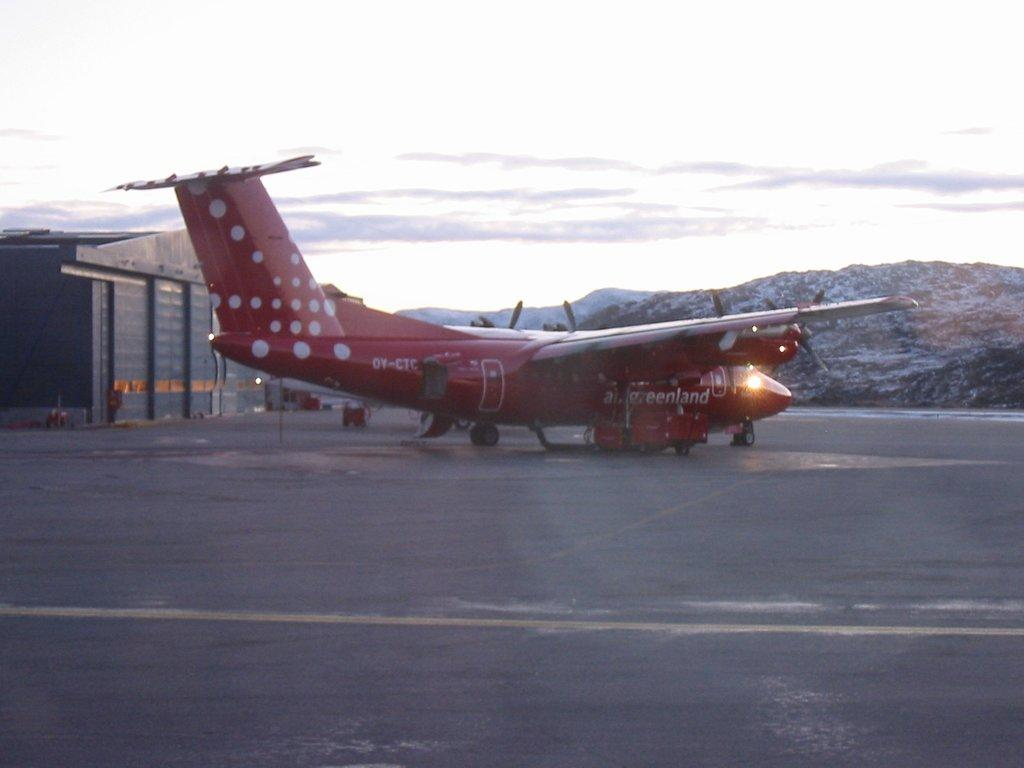What is the unusual object on the road in the image? There is an airplane on the road in the image. What type of structure can be seen in the image? There is a shed in the image. What can be seen in the distance in the image? Hills are visible in the background of the image. What is visible in the sky in the image? The sky is visible in the background, and clouds are present. What type of bit is being used to control the airplane on the road? There is no bit present in the image, as the airplane is not a horse or any other animal that would require a bit for control. 